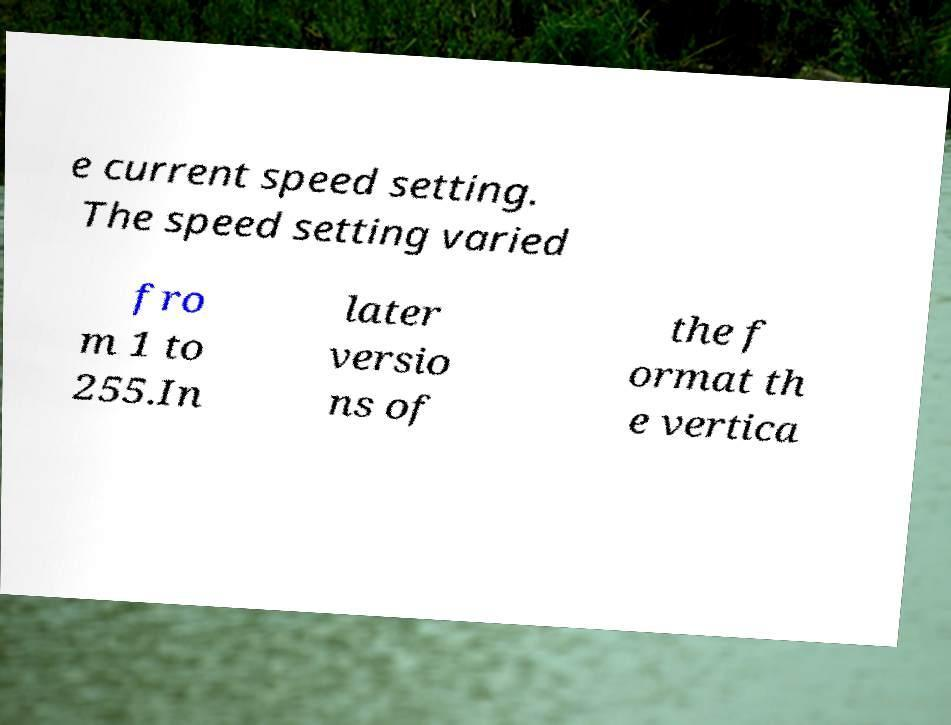For documentation purposes, I need the text within this image transcribed. Could you provide that? e current speed setting. The speed setting varied fro m 1 to 255.In later versio ns of the f ormat th e vertica 